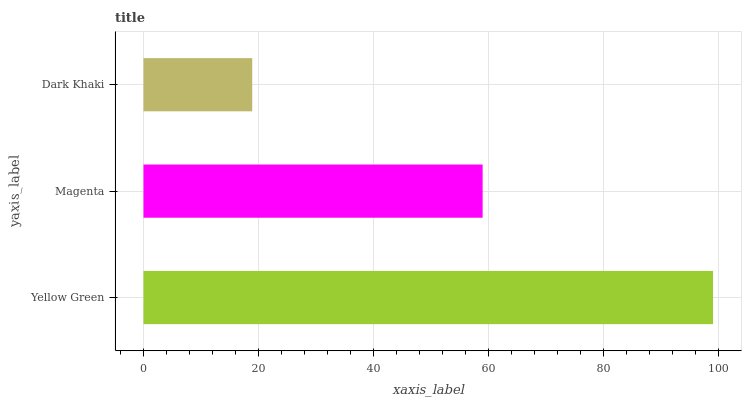Is Dark Khaki the minimum?
Answer yes or no. Yes. Is Yellow Green the maximum?
Answer yes or no. Yes. Is Magenta the minimum?
Answer yes or no. No. Is Magenta the maximum?
Answer yes or no. No. Is Yellow Green greater than Magenta?
Answer yes or no. Yes. Is Magenta less than Yellow Green?
Answer yes or no. Yes. Is Magenta greater than Yellow Green?
Answer yes or no. No. Is Yellow Green less than Magenta?
Answer yes or no. No. Is Magenta the high median?
Answer yes or no. Yes. Is Magenta the low median?
Answer yes or no. Yes. Is Dark Khaki the high median?
Answer yes or no. No. Is Yellow Green the low median?
Answer yes or no. No. 